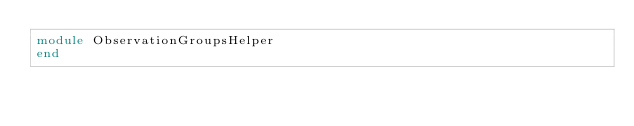<code> <loc_0><loc_0><loc_500><loc_500><_Ruby_>module ObservationGroupsHelper
end
</code> 